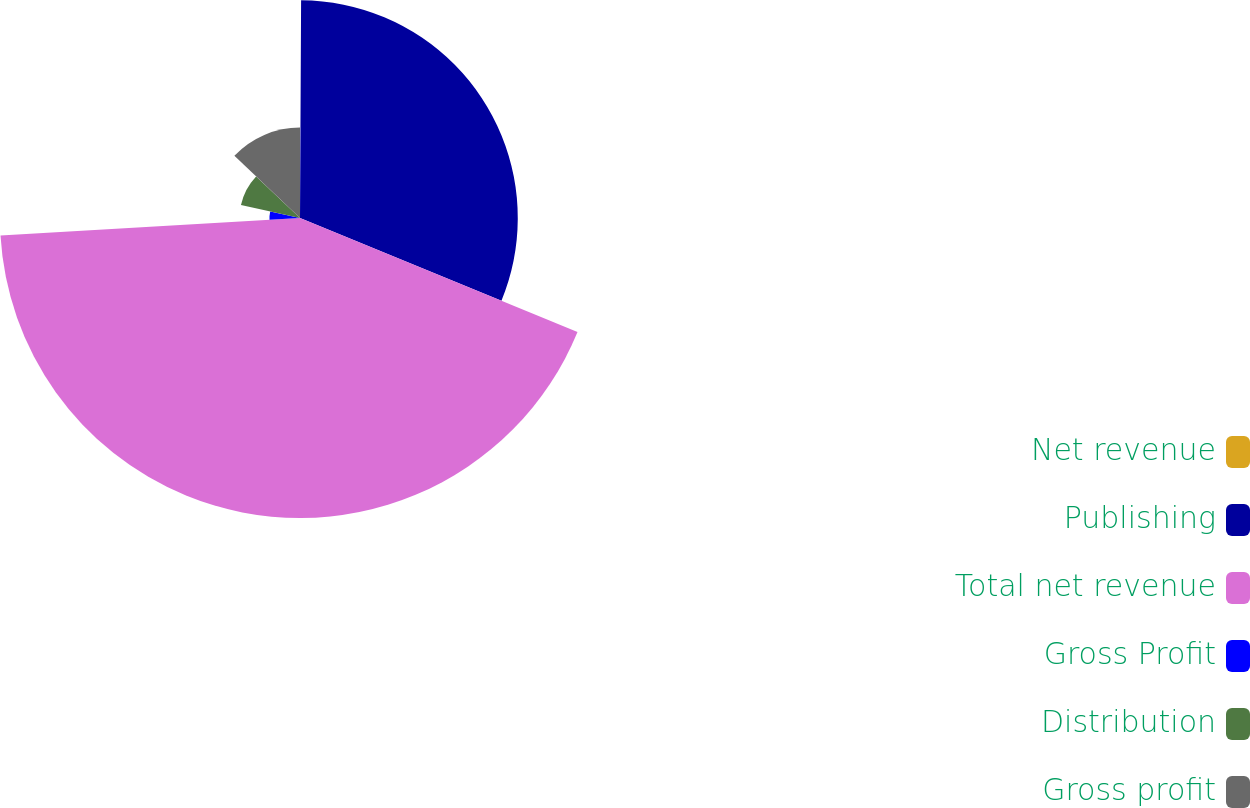Convert chart to OTSL. <chart><loc_0><loc_0><loc_500><loc_500><pie_chart><fcel>Net revenue<fcel>Publishing<fcel>Total net revenue<fcel>Gross Profit<fcel>Distribution<fcel>Gross profit<nl><fcel>0.08%<fcel>31.12%<fcel>42.87%<fcel>4.36%<fcel>8.64%<fcel>12.92%<nl></chart> 